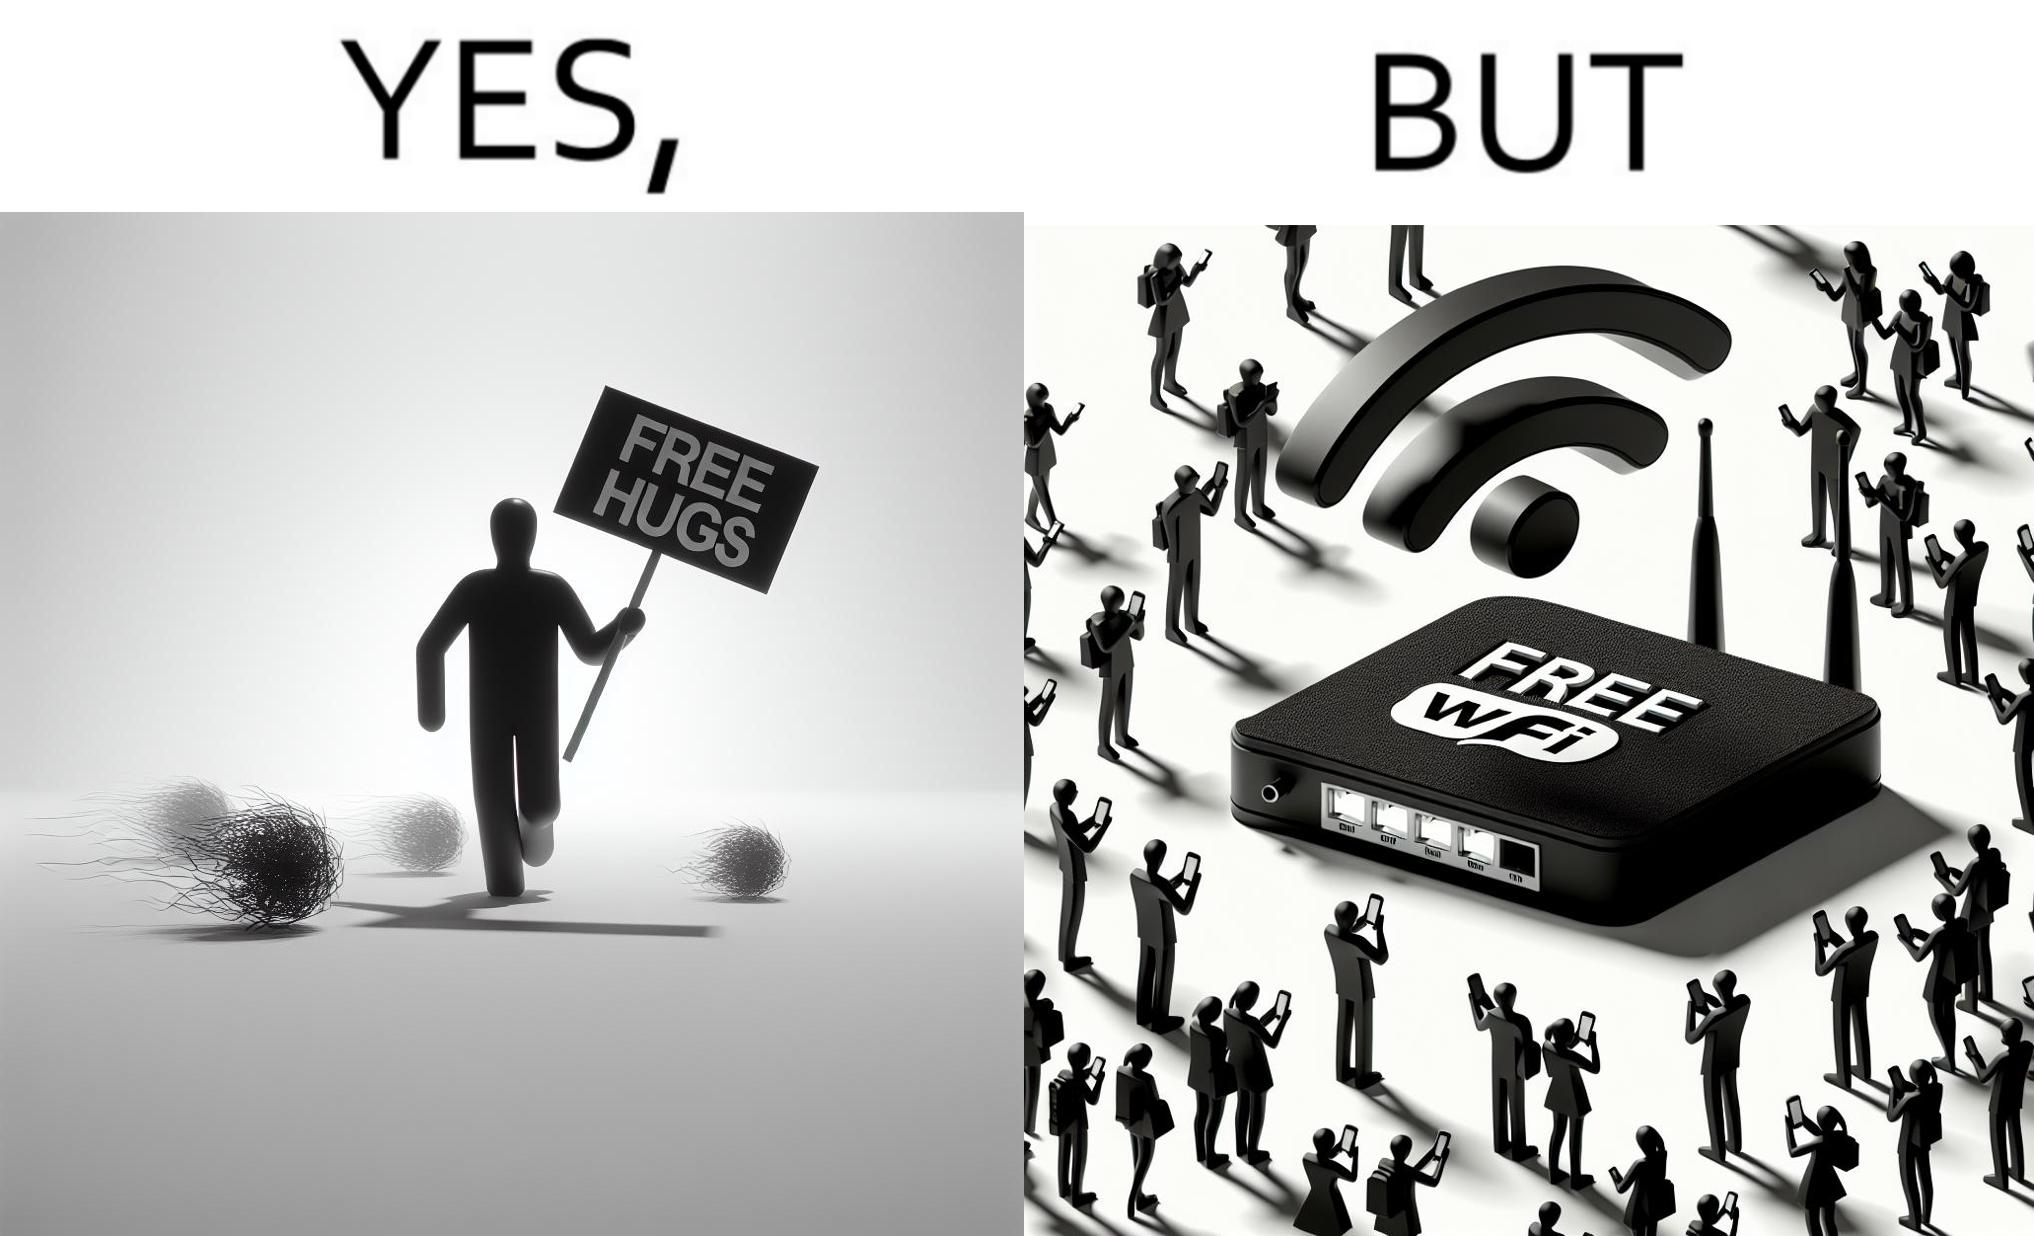Describe the satirical element in this image. This image is ironical, as a person holding up a "Free Hugs" sign is standing alone, while an inanimate Wi-fi Router giving "Free Wifi" is surrounded people trying to connect to it. This shows a growing lack of empathy in our society, while showing our increasing dependence on the digital devices in a virtual world. 